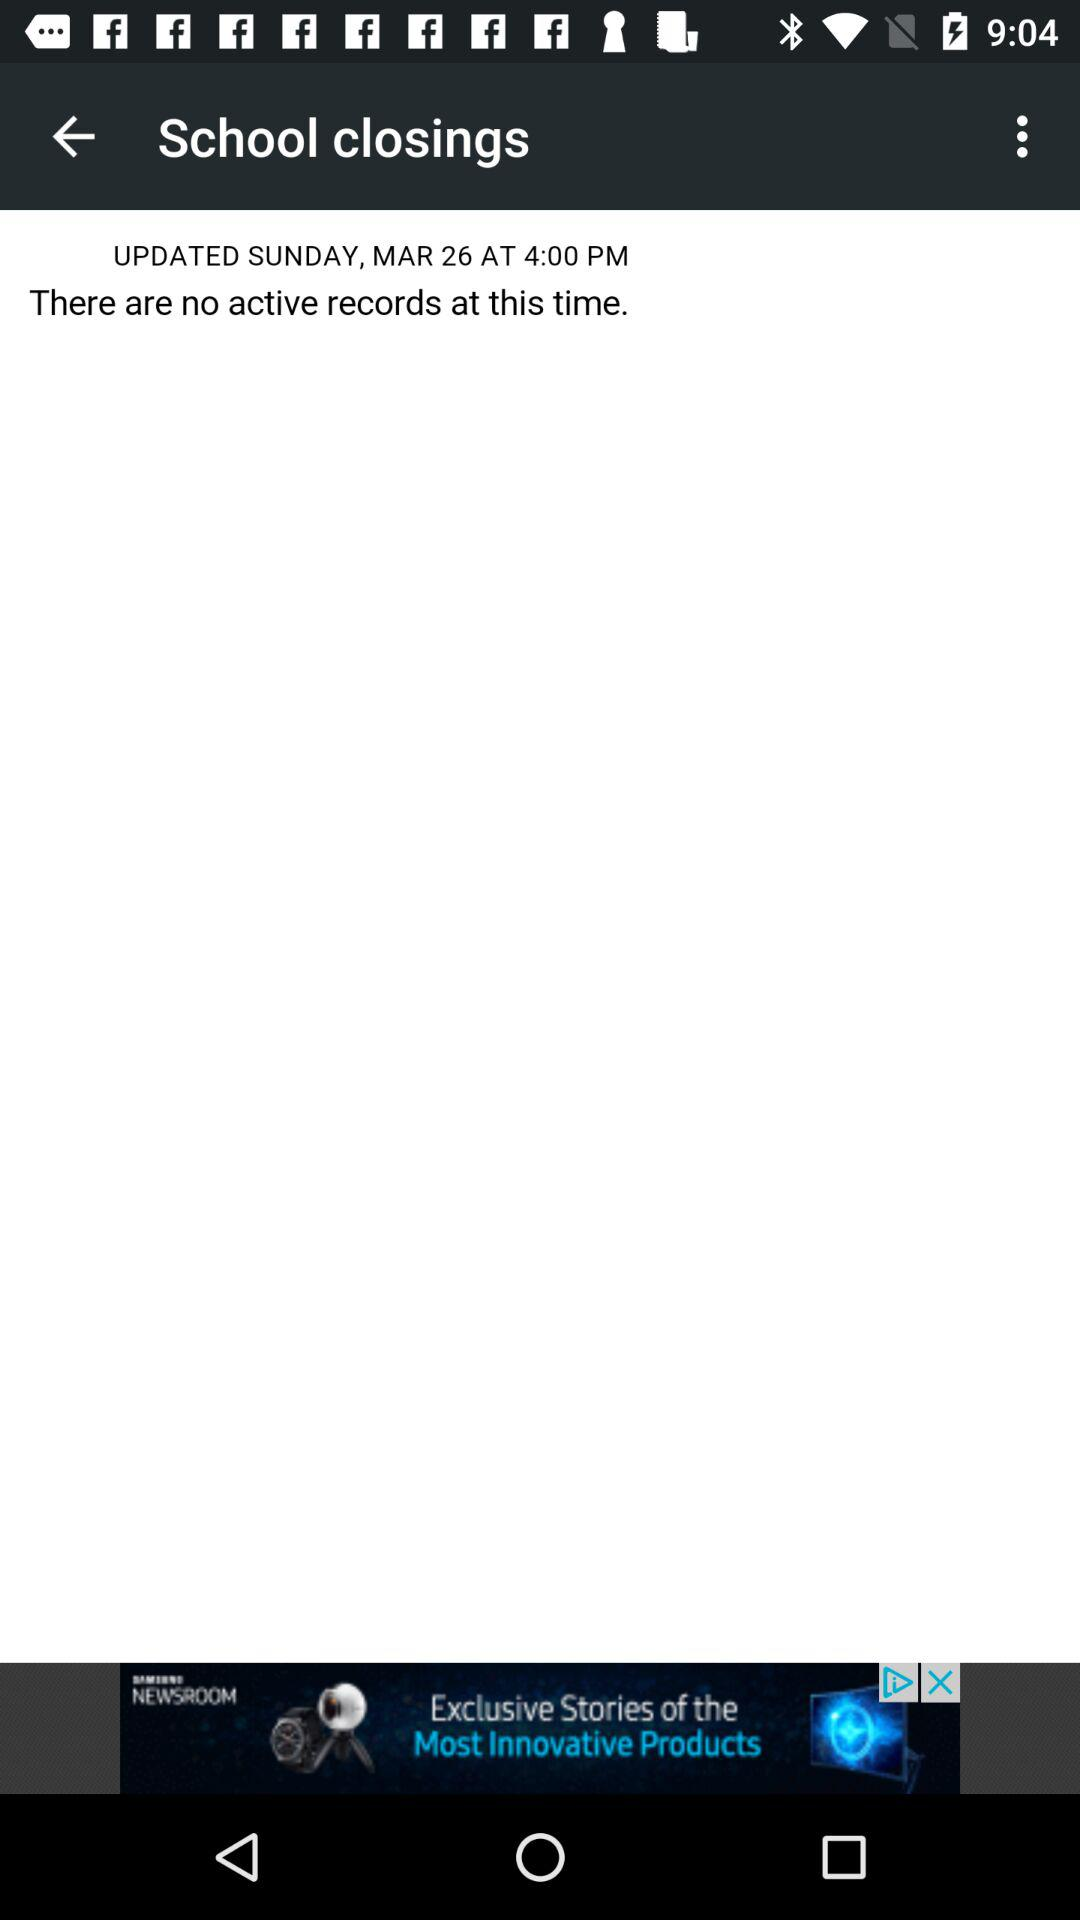When was the last time the information in this record was updated? The information in this record was last updated on Sunday, March 26 at 4 PM. 